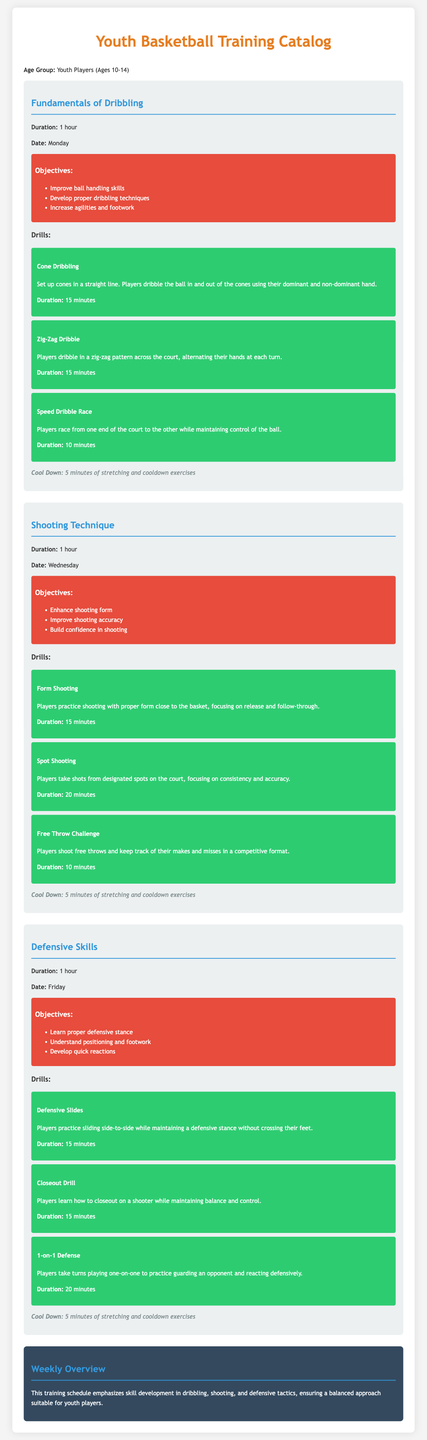What is the first training session offered? The first training session listed in the document is "Fundamentals of Dribbling."
Answer: Fundamentals of Dribbling How long is each training session? Each training session's duration is mentioned as 1 hour.
Answer: 1 hour On which day is the Shooting Technique session held? The document specifies that the Shooting Technique session takes place on Wednesday.
Answer: Wednesday What is one objective of the Defensive Skills session? One of the objectives listed for the Defensive Skills session is to "Learn proper defensive stance."
Answer: Learn proper defensive stance How many drills are included in the Fundamentals of Dribbling? The document lists a total of three drills under the Fundamentals of Dribbling session.
Answer: Three What is the duration of the Cone Dribbling drill? The specific duration for the Cone Dribbling drill is mentioned as 15 minutes.
Answer: 15 minutes What color is used for the objectives section? The objectives section is highlighted in red, which corresponds to the hex color #e74c3c.
Answer: Red What is included in the cool down for all sessions? Each session includes 5 minutes of stretching and cooldown exercises as part of the cool down.
Answer: 5 minutes of stretching and cooldown exercises 